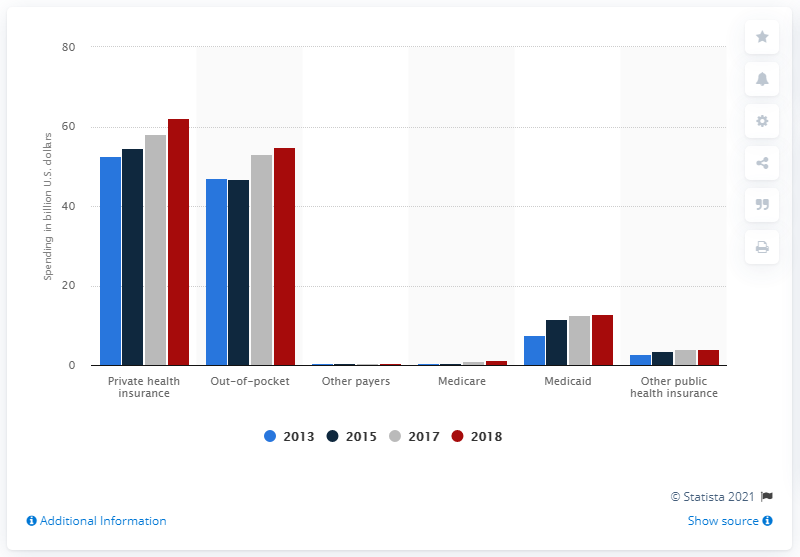Highlight a few significant elements in this photo. In 2018, private health insurance paid approximately $62.2 billion for dental services. 